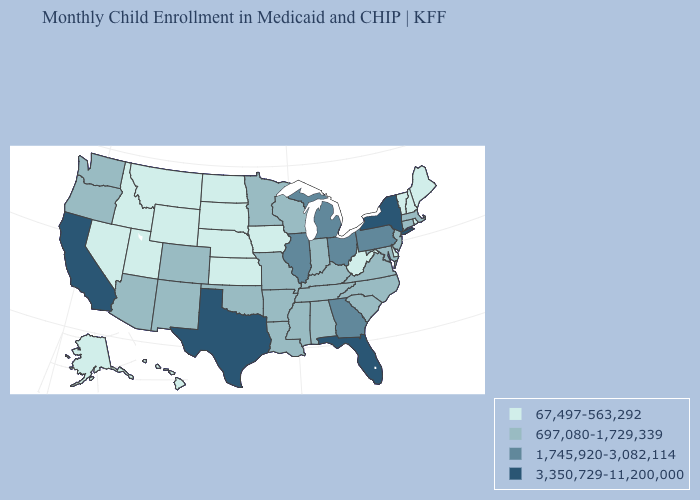Which states have the lowest value in the USA?
Concise answer only. Alaska, Delaware, Hawaii, Idaho, Iowa, Kansas, Maine, Montana, Nebraska, Nevada, New Hampshire, North Dakota, Rhode Island, South Dakota, Utah, Vermont, West Virginia, Wyoming. Which states hav the highest value in the West?
Concise answer only. California. Does the map have missing data?
Short answer required. No. Does the first symbol in the legend represent the smallest category?
Quick response, please. Yes. Which states have the lowest value in the Northeast?
Short answer required. Maine, New Hampshire, Rhode Island, Vermont. What is the value of Wyoming?
Be succinct. 67,497-563,292. Among the states that border Tennessee , which have the highest value?
Give a very brief answer. Georgia. Name the states that have a value in the range 1,745,920-3,082,114?
Concise answer only. Georgia, Illinois, Michigan, Ohio, Pennsylvania. What is the value of Idaho?
Concise answer only. 67,497-563,292. Name the states that have a value in the range 3,350,729-11,200,000?
Quick response, please. California, Florida, New York, Texas. Does Iowa have the highest value in the MidWest?
Quick response, please. No. Does Minnesota have the same value as West Virginia?
Give a very brief answer. No. Name the states that have a value in the range 3,350,729-11,200,000?
Keep it brief. California, Florida, New York, Texas. What is the highest value in states that border Mississippi?
Write a very short answer. 697,080-1,729,339. Name the states that have a value in the range 1,745,920-3,082,114?
Concise answer only. Georgia, Illinois, Michigan, Ohio, Pennsylvania. 